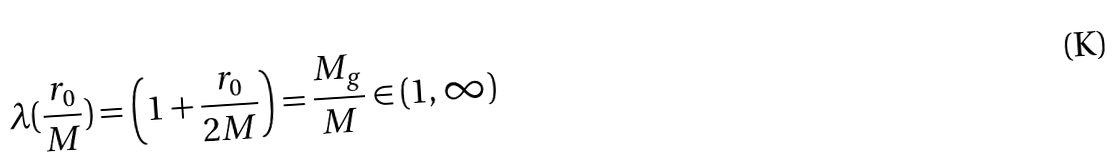Convert formula to latex. <formula><loc_0><loc_0><loc_500><loc_500>\lambda ( \frac { r _ { 0 } } { M } ) = \left ( 1 + \frac { r _ { 0 } } { 2 M } \right ) = \frac { M _ { g } } { M } \in ( 1 , \infty )</formula> 